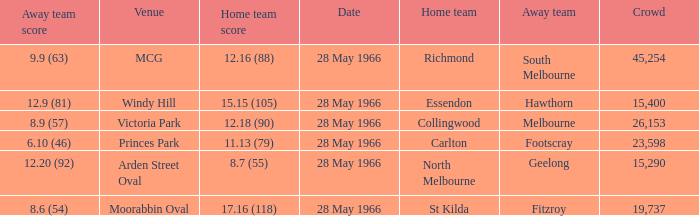Can you parse all the data within this table? {'header': ['Away team score', 'Venue', 'Home team score', 'Date', 'Home team', 'Away team', 'Crowd'], 'rows': [['9.9 (63)', 'MCG', '12.16 (88)', '28 May 1966', 'Richmond', 'South Melbourne', '45,254'], ['12.9 (81)', 'Windy Hill', '15.15 (105)', '28 May 1966', 'Essendon', 'Hawthorn', '15,400'], ['8.9 (57)', 'Victoria Park', '12.18 (90)', '28 May 1966', 'Collingwood', 'Melbourne', '26,153'], ['6.10 (46)', 'Princes Park', '11.13 (79)', '28 May 1966', 'Carlton', 'Footscray', '23,598'], ['12.20 (92)', 'Arden Street Oval', '8.7 (55)', '28 May 1966', 'North Melbourne', 'Geelong', '15,290'], ['8.6 (54)', 'Moorabbin Oval', '17.16 (118)', '28 May 1966', 'St Kilda', 'Fitzroy', '19,737']]} Which Crowd has a Home team of richmond? 45254.0. 